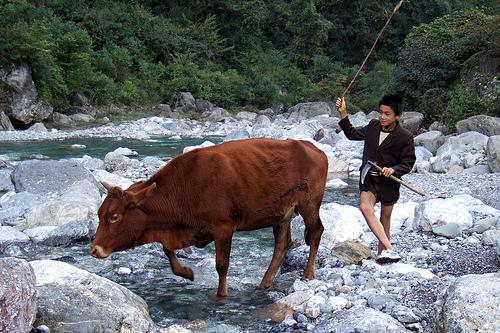Question: what color are the rocks?
Choices:
A. Gray.
B. Brown.
C. Black.
D. White.
Answer with the letter. Answer: A Question: who is behind the cow?
Choices:
A. The farmer.
B. The boy.
C. The girl.
D. The milkmaid.
Answer with the letter. Answer: B 